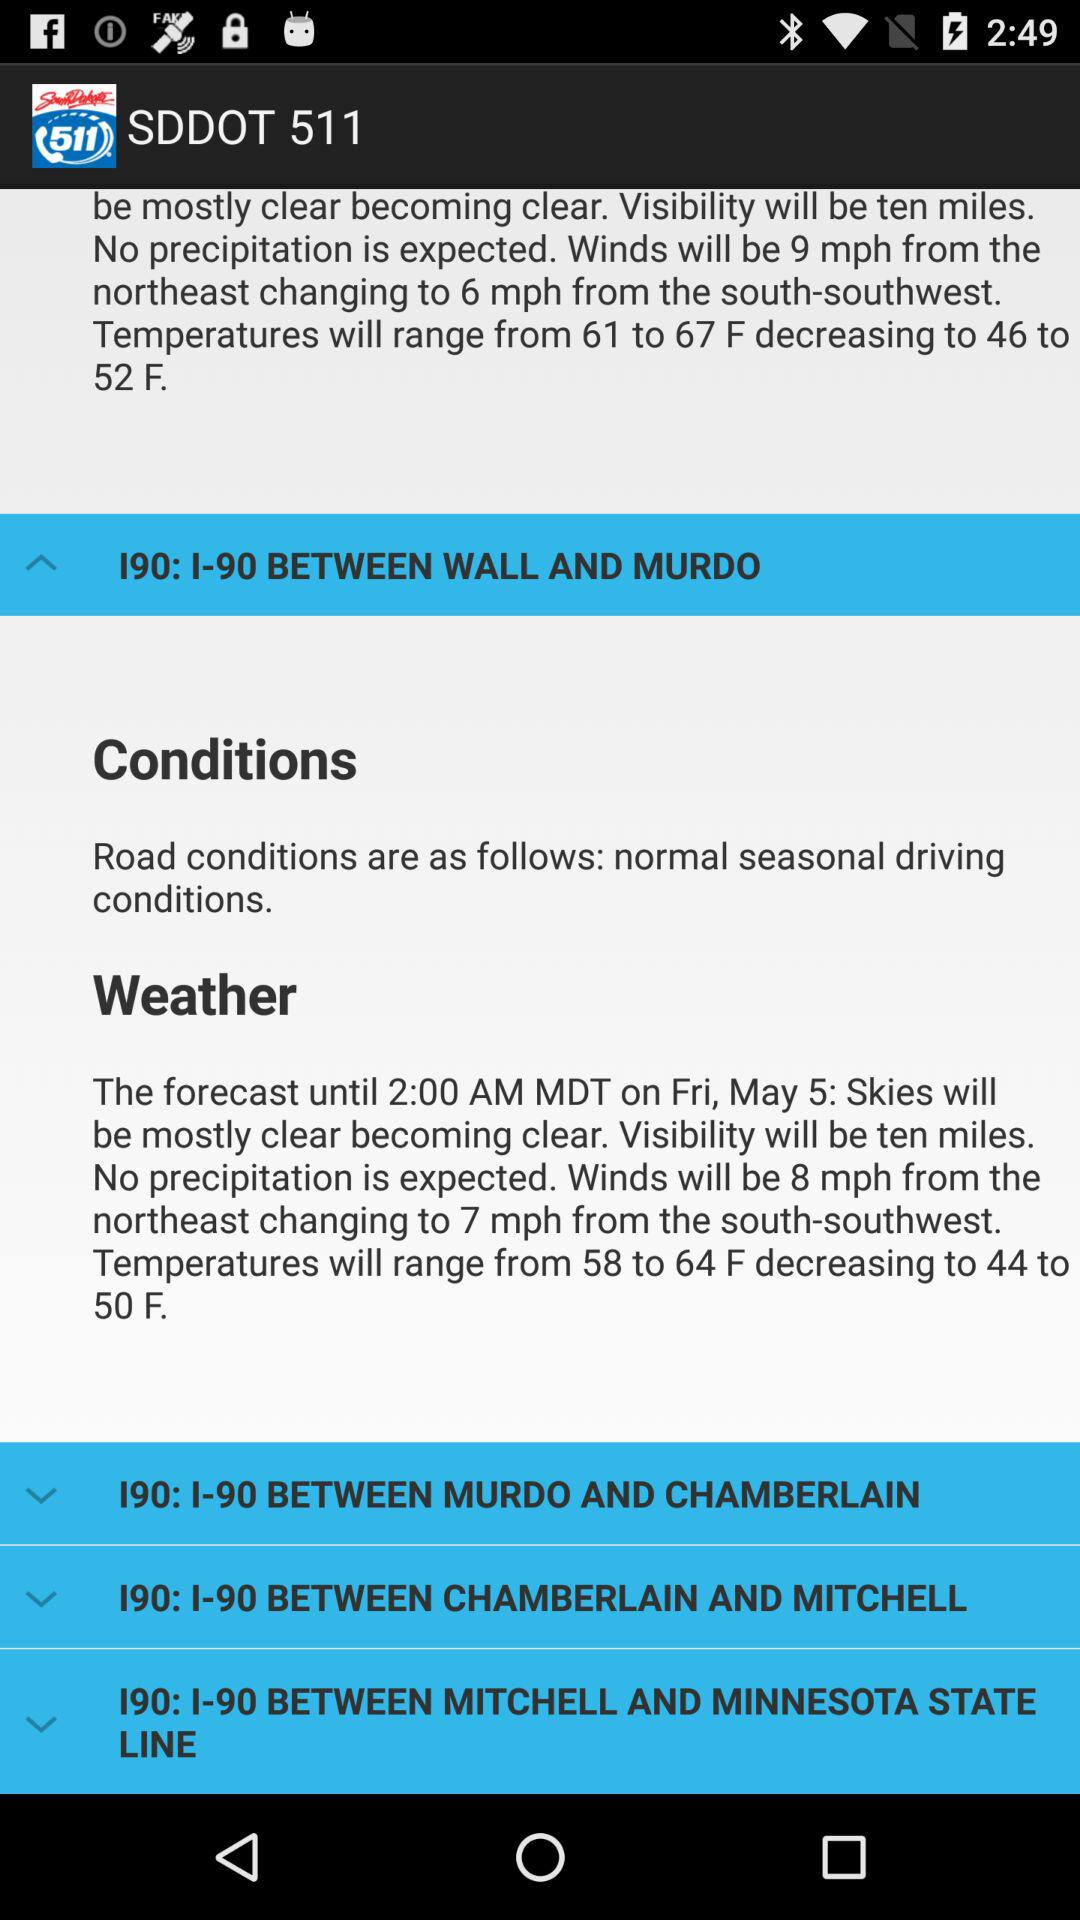What will be the weather on the 5th of May until 2:00 AM MDT? The weather on Friday May 5th: "Skies will be mostly clear becoming clear. Visibility will be ten miles. No precipitation is expected. Winds will be 8 mph from the northeast changing to 7 mph from the south-southwest. Temperatures will range from 58 to 64 F decreasing to 44 to 50 F.". 